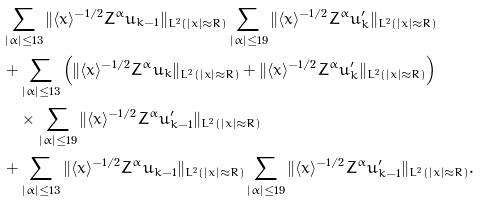<formula> <loc_0><loc_0><loc_500><loc_500>& \sum _ { | \alpha | \leq 1 3 } \| \langle x \rangle ^ { - 1 / 2 } Z ^ { \alpha } u _ { k - 1 } \| _ { L ^ { 2 } ( | x | \approx R ) } \sum _ { | \alpha | \leq 1 9 } \| \langle x \rangle ^ { - 1 / 2 } Z ^ { \alpha } u ^ { \prime } _ { k } \| _ { L ^ { 2 } ( | x | \approx R ) } \\ & + \sum _ { | \alpha | \leq 1 3 } \left ( \| \langle x \rangle ^ { - 1 / 2 } Z ^ { \alpha } u _ { k } \| _ { L ^ { 2 } ( | x | \approx R ) } + \| \langle x \rangle ^ { - 1 / 2 } Z ^ { \alpha } u ^ { \prime } _ { k } \| _ { L ^ { 2 } ( | x | \approx R ) } \right ) \\ & \quad \times \sum _ { | \alpha | \leq 1 9 } \| \langle x \rangle ^ { - 1 / 2 } Z ^ { \alpha } u ^ { \prime } _ { k - 1 } \| _ { L ^ { 2 } ( | x | \approx R ) } \\ & + \sum _ { | \alpha | \leq 1 3 } \| \langle x \rangle ^ { - 1 / 2 } Z ^ { \alpha } u _ { k - 1 } \| _ { L ^ { 2 } ( | x | \approx R ) } \sum _ { | \alpha | \leq 1 9 } \| \langle x \rangle ^ { - 1 / 2 } Z ^ { \alpha } u ^ { \prime } _ { k - 1 } \| _ { L ^ { 2 } ( | x | \approx R ) } .</formula> 